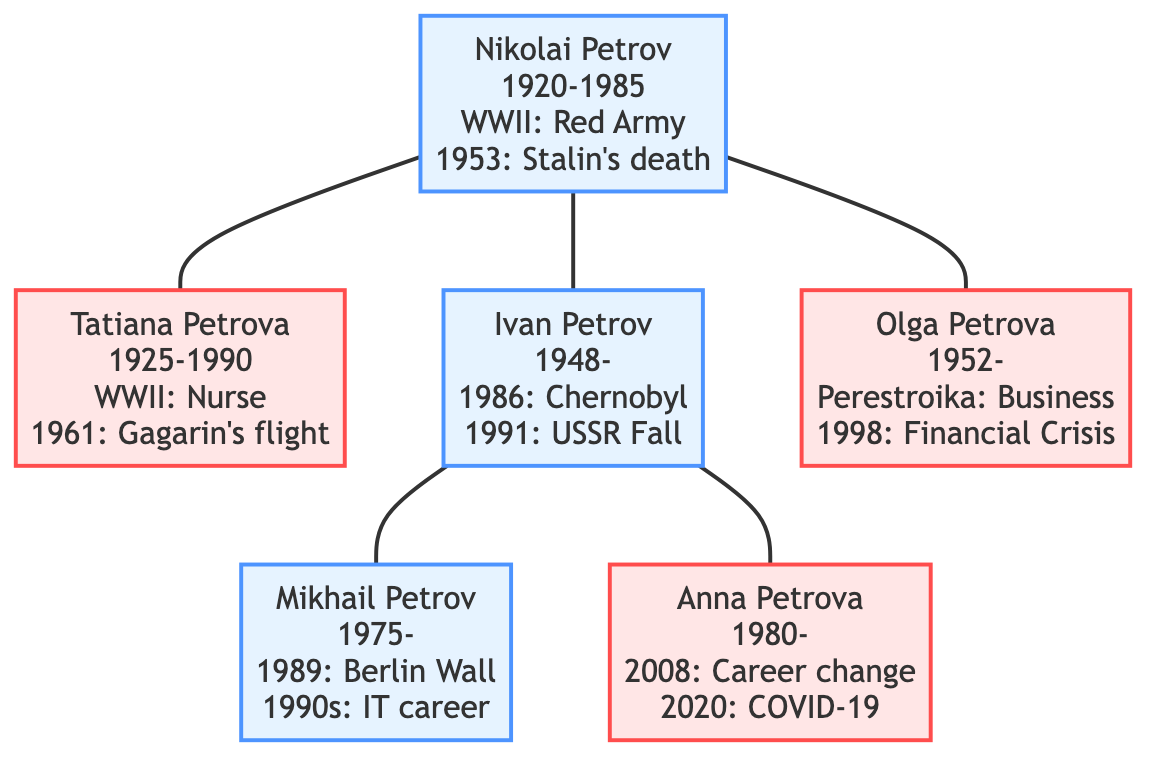What military conflict did Nikolai Petrov serve in? The diagram shows an event labeled "WWII" associated with Nikolai Petrov, indicating he served in the military during this conflict.
Answer: WWII What year was Tatiana Petrova born? The diagram displays Tatiana Petrova's birth year next to her name. It clearly shows her birth year as 1925.
Answer: 1925 Who worked as a nurse during World War II? The diagram indicates that "Tatiana Petrova" is associated with the event "WWII", which states she worked as a nurse in field hospitals.
Answer: Tatiana Petrova How did Ivan Petrov's experience in 1986 affect him? The diagram provides an event for Ivan Petrov labeled "Chernobyl Disaster 1986", and the associated impact states he faced health issues due to fallout.
Answer: Health issues Which family member experienced economic instability due to the fall of the Soviet Union? The diagram shows that Ivan Petrov is associated with the event "Fall of the Soviet Union 1991", which indicates he experienced economic instability and job loss.
Answer: Ivan Petrov What event shaped Mikhail Petrov's interest in Western culture? According to the diagram, Mikhail Petrov's interest in Western culture is linked to the event "Fall of the Berlin Wall 1989."
Answer: Fall of the Berlin Wall How many key events are associated with Olga Petrova? The diagram lists two key events under Olga Petrova's name: "Perestroika" and "1998 Russian Financial Crisis." Therefore, there are two events associated with her.
Answer: 2 Which family member adapted to economic reforms during Perestroika? The diagram states that "Olga Petrova" adapted to new economic reforms during "Perestroika" shown next to her name.
Answer: Olga Petrova What was the year of Anna Petrova's birth? The diagram provides Anna Petrova's birth year, which is clearly marked as 1980 beside her name.
Answer: 1980 What major global event did Anna Petrova face difficulties with in 2008? The diagram indicates an event for Anna Petrova labeled "2008 Global Financial Crisis," specifying that it led to job market difficulties for her.
Answer: 2008 Global Financial Crisis 